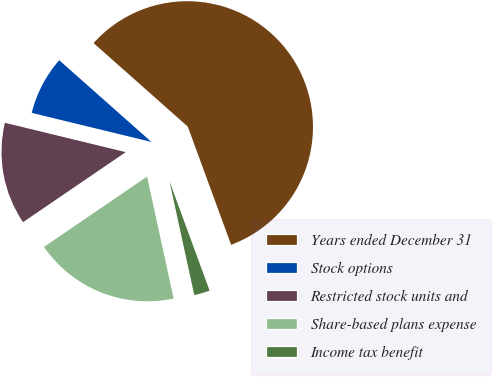Convert chart to OTSL. <chart><loc_0><loc_0><loc_500><loc_500><pie_chart><fcel>Years ended December 31<fcel>Stock options<fcel>Restricted stock units and<fcel>Share-based plans expense<fcel>Income tax benefit<nl><fcel>57.86%<fcel>7.75%<fcel>13.32%<fcel>18.89%<fcel>2.18%<nl></chart> 